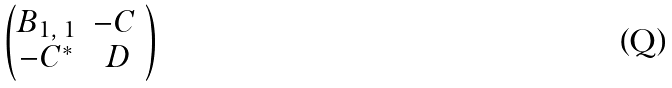<formula> <loc_0><loc_0><loc_500><loc_500>\begin{pmatrix} B _ { 1 , \, 1 } & - C \ \\ - C ^ { * } & D \end{pmatrix}</formula> 